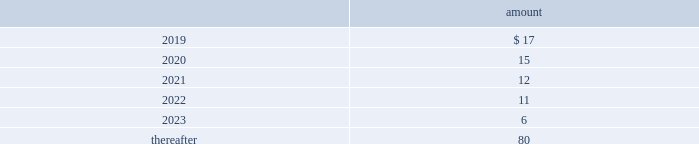The table provides the minimum annual future rental commitment under operating leases that have initial or remaining non-cancelable lease terms over the next five years and thereafter: .
The company has a series of agreements with various public entities ( the 201cpartners 201d ) to establish certain joint ventures , commonly referred to as 201cpublic-private partnerships . 201d under the public-private partnerships , the company constructed utility plant , financed by the company , and the partners constructed utility plant ( connected to the company 2019s property ) , financed by the partners .
The company agreed to transfer and convey some of its real and personal property to the partners in exchange for an equal principal amount of industrial development bonds ( 201cidbs 201d ) , issued by the partners under a state industrial development bond and commercial development act .
The company leased back the total facilities , including portions funded by both the company and the partners , under leases for a period of 40 years .
The leases related to the portion of the facilities funded by the company have required payments from the company to the partners that approximate the payments required by the terms of the idbs from the partners to the company ( as the holder of the idbs ) .
As the ownership of the portion of the facilities constructed by the company will revert back to the company at the end of the lease , the company has recorded these as capital leases .
The lease obligation and the receivable for the principal amount of the idbs are presented by the company on a net basis .
The carrying value of the facilities funded by the company recognized as a capital lease asset was $ 147 million and $ 150 million as of december 31 , 2018 and 2017 , respectively , which is presented in property , plant and equipment on the consolidated balance sheets .
The future payments under the lease obligations are equal to and offset by the payments receivable under the idbs .
As of december 31 , 2018 , the minimum annual future rental commitment under the operating leases for the portion of the facilities funded by the partners that have initial or remaining non-cancelable lease terms in excess of one year included in the preceding minimum annual rental commitments are $ 4 million in 2019 through 2023 , and $ 59 million thereafter .
Note 20 : segment information the company 2019s operating segments are comprised of the revenue-generating components of its businesses for which separate financial information is internally produced and regularly used by management to make operating decisions and assess performance .
The company operates its businesses primarily through one reportable segment , the regulated businesses segment .
The company also operates market-based businesses that provide a broad range of related and complementary water and wastewater services within non-reportable operating segments , collectively referred to as the market-based businesses .
The regulated businesses segment is the largest component of the company 2019s business and includes 20 subsidiaries that provide water and wastewater services to customers in 16 states .
The company 2019s primary market-based businesses include the homeowner services group , which provides warranty protection programs to residential and smaller commercial customers ; the military services group , which provides water and wastewater services to the u.s .
Government on military installations ; and keystone , which provides water transfer services for shale natural gas exploration and production companies. .
For 2021 and 2022 , what were total millions of minimum annual future rental commitment under operating leases that have initial or remaining non-cancelable lease terms? 
Computations: (12 + 11)
Answer: 23.0. The table provides the minimum annual future rental commitment under operating leases that have initial or remaining non-cancelable lease terms over the next five years and thereafter: .
The company has a series of agreements with various public entities ( the 201cpartners 201d ) to establish certain joint ventures , commonly referred to as 201cpublic-private partnerships . 201d under the public-private partnerships , the company constructed utility plant , financed by the company , and the partners constructed utility plant ( connected to the company 2019s property ) , financed by the partners .
The company agreed to transfer and convey some of its real and personal property to the partners in exchange for an equal principal amount of industrial development bonds ( 201cidbs 201d ) , issued by the partners under a state industrial development bond and commercial development act .
The company leased back the total facilities , including portions funded by both the company and the partners , under leases for a period of 40 years .
The leases related to the portion of the facilities funded by the company have required payments from the company to the partners that approximate the payments required by the terms of the idbs from the partners to the company ( as the holder of the idbs ) .
As the ownership of the portion of the facilities constructed by the company will revert back to the company at the end of the lease , the company has recorded these as capital leases .
The lease obligation and the receivable for the principal amount of the idbs are presented by the company on a net basis .
The carrying value of the facilities funded by the company recognized as a capital lease asset was $ 147 million and $ 150 million as of december 31 , 2018 and 2017 , respectively , which is presented in property , plant and equipment on the consolidated balance sheets .
The future payments under the lease obligations are equal to and offset by the payments receivable under the idbs .
As of december 31 , 2018 , the minimum annual future rental commitment under the operating leases for the portion of the facilities funded by the partners that have initial or remaining non-cancelable lease terms in excess of one year included in the preceding minimum annual rental commitments are $ 4 million in 2019 through 2023 , and $ 59 million thereafter .
Note 20 : segment information the company 2019s operating segments are comprised of the revenue-generating components of its businesses for which separate financial information is internally produced and regularly used by management to make operating decisions and assess performance .
The company operates its businesses primarily through one reportable segment , the regulated businesses segment .
The company also operates market-based businesses that provide a broad range of related and complementary water and wastewater services within non-reportable operating segments , collectively referred to as the market-based businesses .
The regulated businesses segment is the largest component of the company 2019s business and includes 20 subsidiaries that provide water and wastewater services to customers in 16 states .
The company 2019s primary market-based businesses include the homeowner services group , which provides warranty protection programs to residential and smaller commercial customers ; the military services group , which provides water and wastewater services to the u.s .
Government on military installations ; and keystone , which provides water transfer services for shale natural gas exploration and production companies. .
What percentage of the minimum annual future rental commitment under operating leases that have initial or remaining non-cancelable lease terms is due in 2019? 
Rationale: from here you need to take the amount due in 2019 or $ 17 and divide it by the total or 141 to get 12.1%
Computations: (((17 + 15) + (12 + 11)) + 80)
Answer: 135.0. 